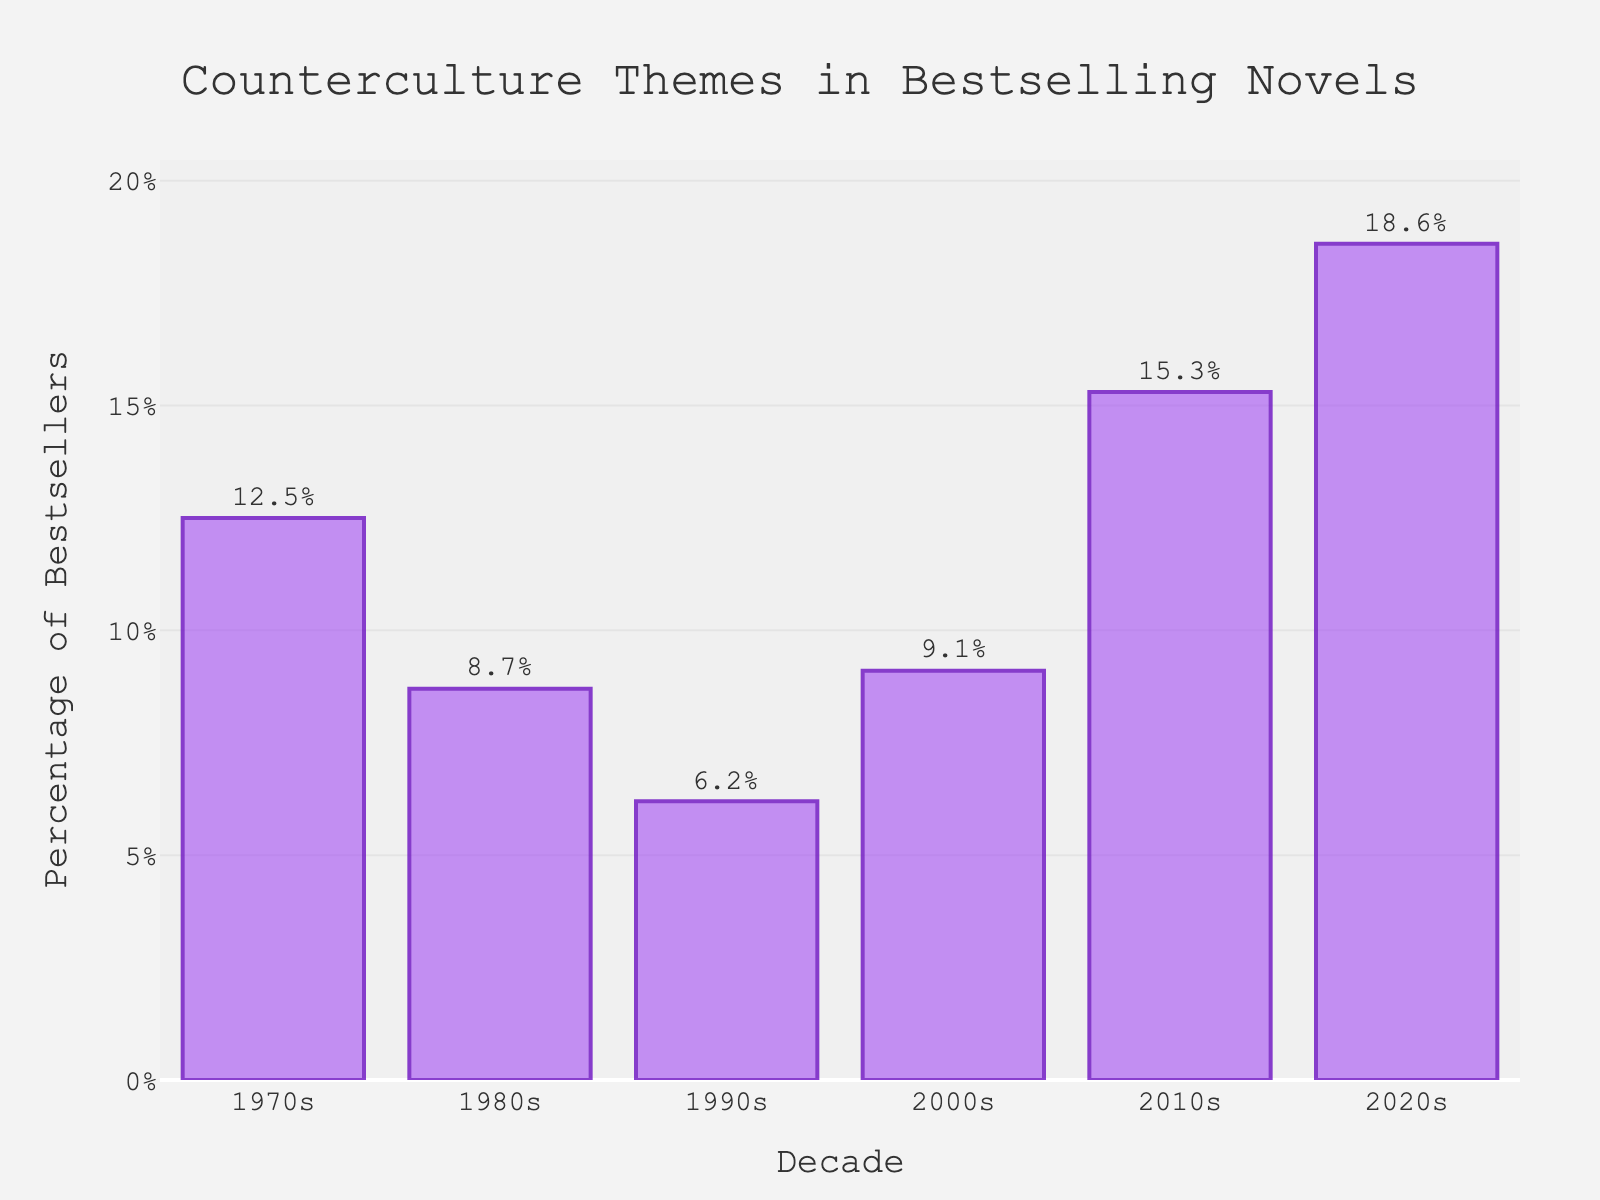What is the percentage of bestselling novels with counterculture themes in the 2010s? Look at the bar corresponding to the 2010s and read the percentage shown on the vertical axis or the annotation above the bar, which is 15.3%.
Answer: 15.3% Which decade has the highest percentage of bestselling novels with counterculture themes? Find the tallest bar in the chart; the bar for the 2020s is the tallest with a percentage of 18.6%.
Answer: 2020s How much did the percentage of bestselling novels with counterculture themes change from the 1990s to the 2000s? Subtract the percentage for the 1990s (6.2%) from the percentage for the 2000s (9.1%), which results in 9.1% - 6.2% = 2.9%.
Answer: 2.9% Compare the percentage of bestselling novels with counterculture themes between the 1980s and the 2020s. Which decade had a higher percentage and by how much? Subtract the percentage for the 1980s (8.7%) from the percentage for the 2020s (18.6%), which is 18.6% - 8.7% = 9.9%. The 2020s have a higher percentage by 9.9%.
Answer: 2020s by 9.9% What is the average percentage of bestselling novels with counterculture themes from the 1970s to the 2020s? Add all the percentages together and divide by the number of decades: (12.5 + 8.7 + 6.2 + 9.1 + 15.3 + 18.6) / 6, which equals 11.73333.
Answer: 11.73% By how much did the percentage of bestselling novels with counterculture themes change from the lowest point in the 1990s to the highest point in the 2020s? Subtract the lowest percentage (6.2% in the 1990s) from the highest percentage (18.6% in the 2020s), which is 18.6% - 6.2% = 12.4%.
Answer: 12.4% Which decade has the second highest percentage of bestselling novels with counterculture themes and what is that percentage? Identify the second tallest bar, which corresponds to the 2010s, with a percentage of 15.3%.
Answer: 2010s, 15.3% What is the total percentage of bestselling novels with counterculture themes for the decades of the 1970s, 1980s, and 1990s combined? Sum the percentages for the 1970s (12.5%), 1980s (8.7%), and 1990s (6.2%): 12.5 + 8.7 + 6.2 = 27.4%.
Answer: 27.4% How does the length of the bar for the 1990s compare to the bar for the 2010s? The bar for the 1990s is shorter than the bar for the 2010s. The percentage for the 1990s is 6.2%, while it's 15.3% for the 2010s, indicating an increase.
Answer: 1990s is shorter 